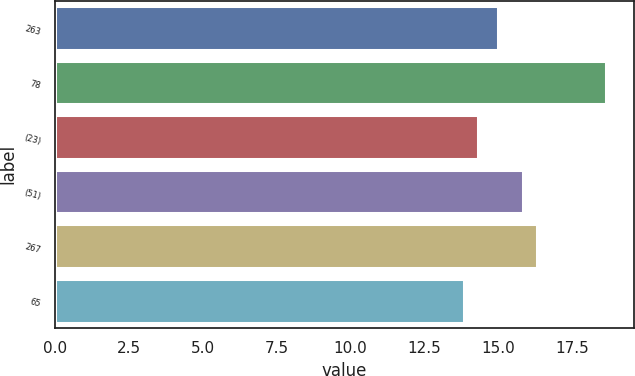Convert chart. <chart><loc_0><loc_0><loc_500><loc_500><bar_chart><fcel>263<fcel>78<fcel>(23)<fcel>(51)<fcel>267<fcel>65<nl><fcel>15<fcel>18.66<fcel>14.32<fcel>15.82<fcel>16.3<fcel>13.84<nl></chart> 